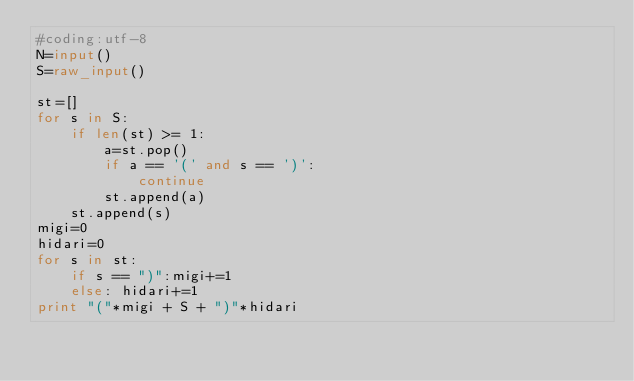<code> <loc_0><loc_0><loc_500><loc_500><_Python_>#coding:utf-8
N=input()
S=raw_input()

st=[]
for s in S:
    if len(st) >= 1:
        a=st.pop()
        if a == '(' and s == ')':
            continue
        st.append(a)
    st.append(s)
migi=0
hidari=0
for s in st:
    if s == ")":migi+=1
    else: hidari+=1
print "("*migi + S + ")"*hidari
</code> 